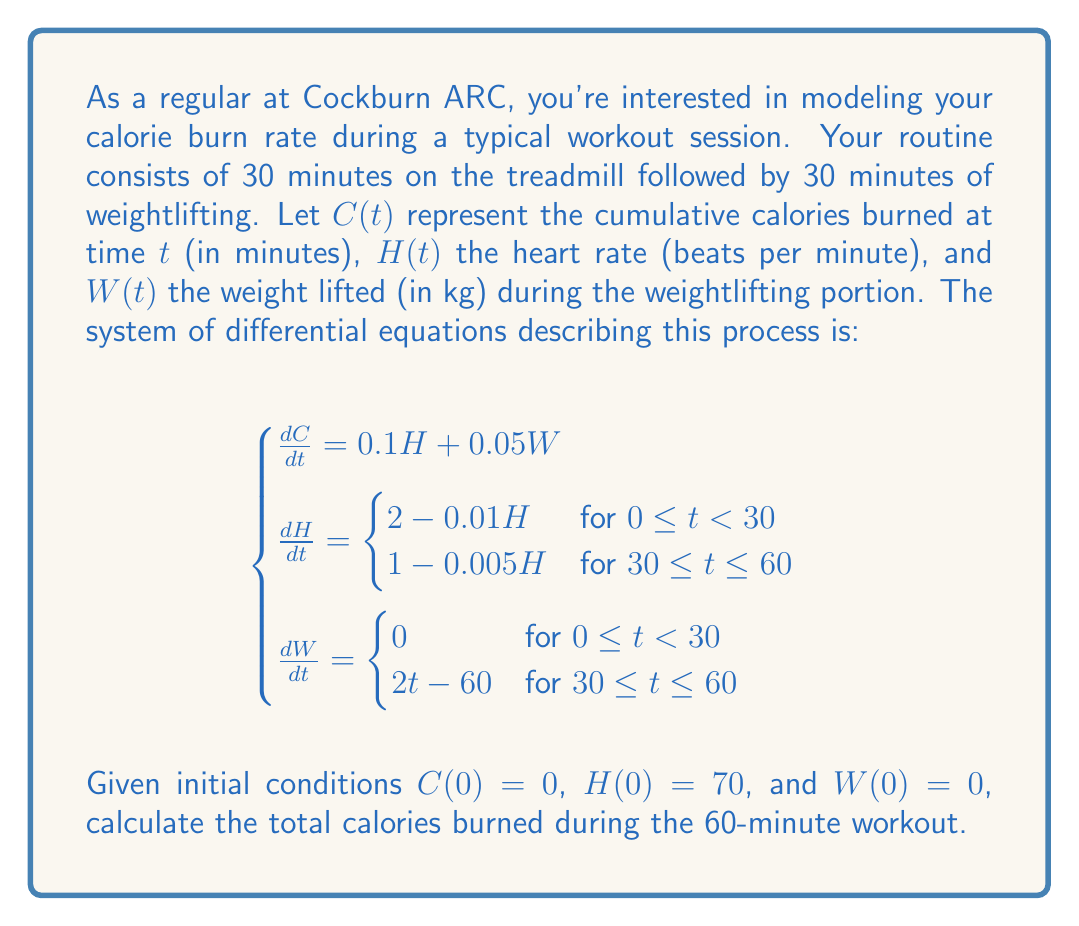Help me with this question. To solve this system, we'll break it down into two 30-minute intervals:

1. For $0 \leq t < 30$ (treadmill):
   $\frac{dH}{dt} = 2 - 0.01H$
   Solving this ODE: $H(t) = 200 - 130e^{-0.01t}$
   $W(t) = 0$
   
   $\frac{dC}{dt} = 0.1H = 20 - 13e^{-0.01t}$
   Integrating: $C(t) = 20t + 1300e^{-0.01t} - 1300$

2. For $30 \leq t \leq 60$ (weightlifting):
   $\frac{dH}{dt} = 1 - 0.005H$
   With $H(30)$ from previous interval, solve: $H(t) = 200 - 33.2e^{-0.005(t-30)}$
   $\frac{dW}{dt} = 2t - 60$, so $W(t) = t^2 - 60t + 900$

   $\frac{dC}{dt} = 0.1H + 0.05W = 20 - 3.32e^{-0.005(t-30)} + 0.05t^2 - 3t + 45$
   Integrating from $t=30$ to $60$, with $C(30)$ from previous interval.

3. Calculate total calories:
   $C(60) = C(30) + \int_{30}^{60} (20 - 3.32e^{-0.005(t-30)} + 0.05t^2 - 3t + 45) dt$

Evaluating these integrals (which involves some complex calculations) gives the total calories burned.
Answer: Approximately 486 calories 